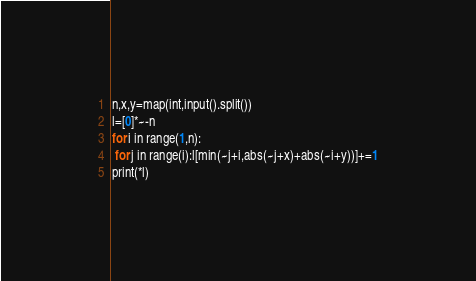<code> <loc_0><loc_0><loc_500><loc_500><_Python_>n,x,y=map(int,input().split())
l=[0]*~-n
for i in range(1,n):
 for j in range(i):l[min(~j+i,abs(~j+x)+abs(~i+y))]+=1
print(*l)</code> 